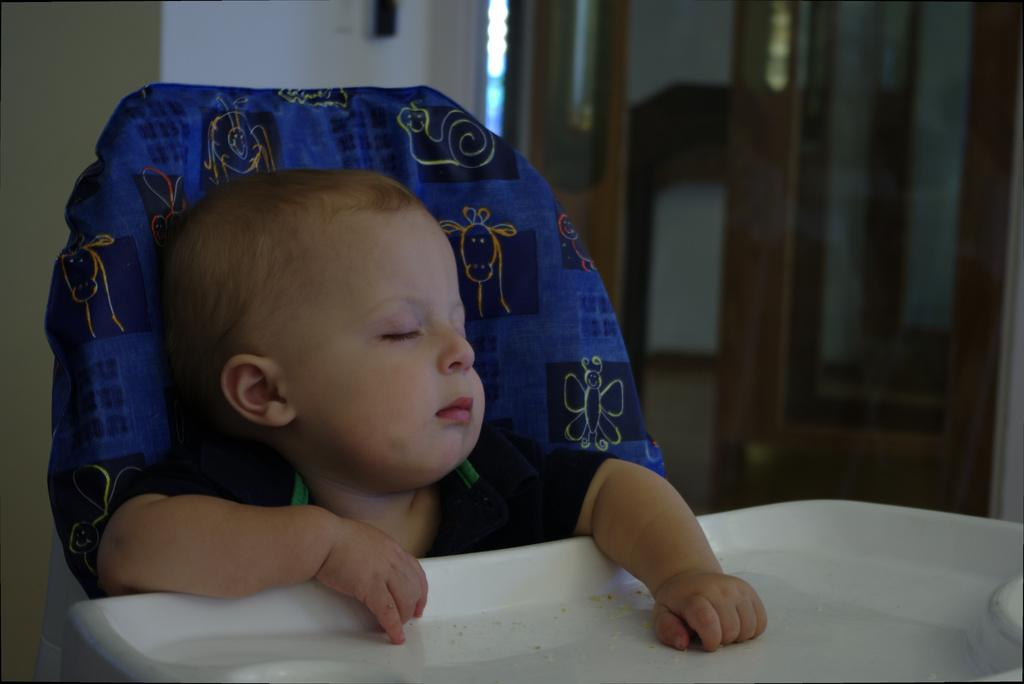What is the main subject of the image? There is a baby in the image. What is the baby doing in the image? The baby is sitting in a chair. Where is the baby located in relation to the table? The baby is in front of a table. What can be seen in the middle of the image? There is a door in the middle of the image. What type of hose is the baby using to water the plants in the image? There is no hose or plants present in the image; it features a baby sitting in a chair in front of a table. Can you tell me where the nearest park is in relation to the baby's location in the image? The image does not provide any information about the location of a park, so it cannot be determined from the image. 